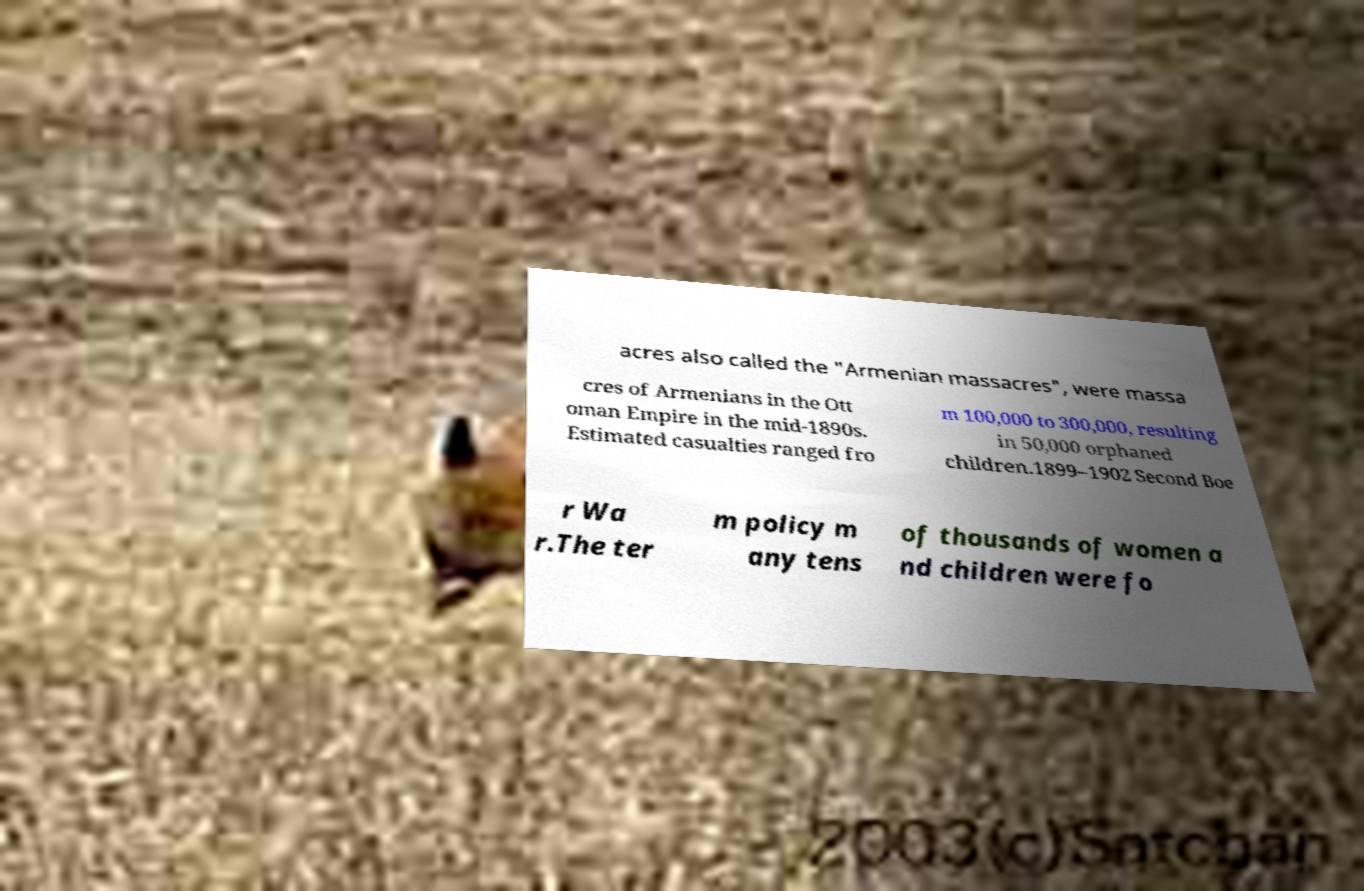Can you read and provide the text displayed in the image?This photo seems to have some interesting text. Can you extract and type it out for me? acres also called the "Armenian massacres", were massa cres of Armenians in the Ott oman Empire in the mid-1890s. Estimated casualties ranged fro m 100,000 to 300,000, resulting in 50,000 orphaned children.1899–1902 Second Boe r Wa r.The ter m policy m any tens of thousands of women a nd children were fo 